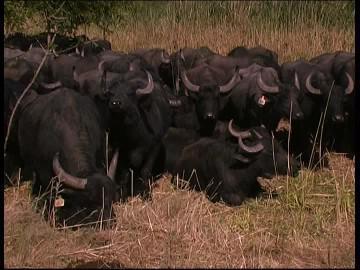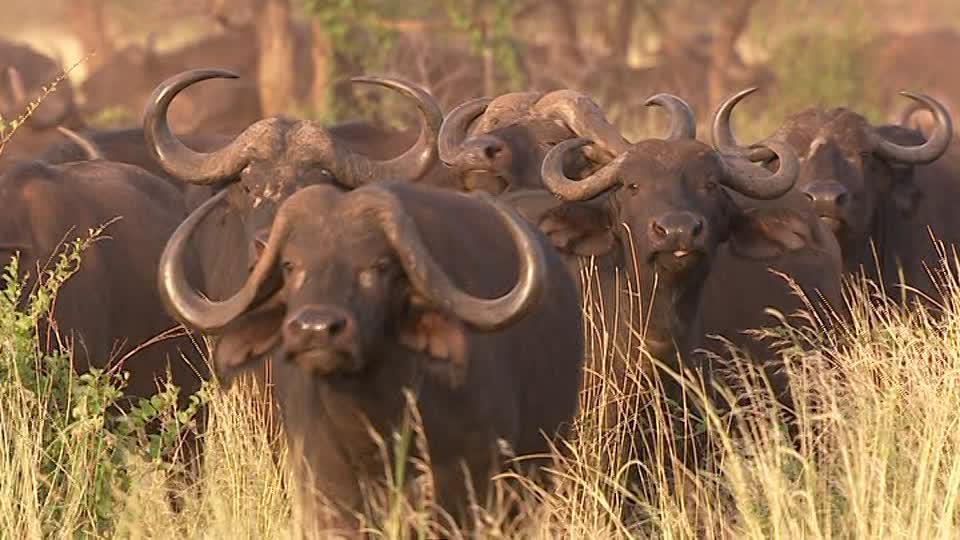The first image is the image on the left, the second image is the image on the right. Analyze the images presented: Is the assertion "The sky is visible in the left image." valid? Answer yes or no. No. The first image is the image on the left, the second image is the image on the right. Given the left and right images, does the statement "In each image, at least one forward-facing water buffalo with raised head is prominent, and no image contains more than a dozen distinguishable buffalo." hold true? Answer yes or no. No. 